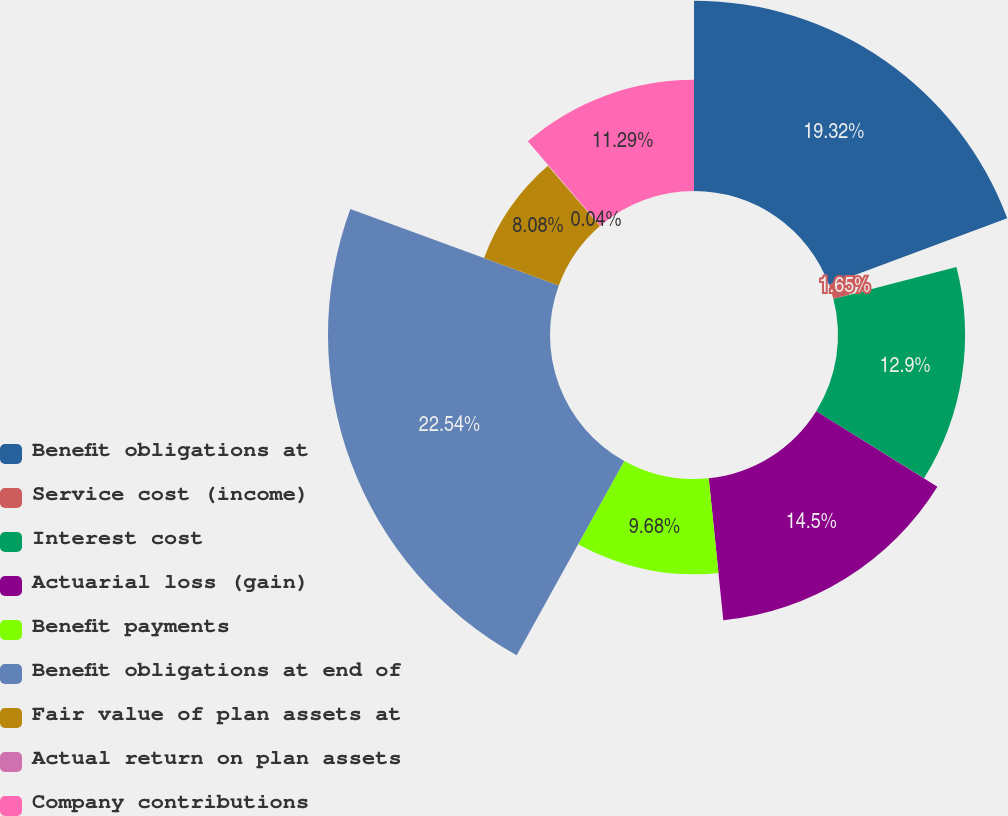Convert chart to OTSL. <chart><loc_0><loc_0><loc_500><loc_500><pie_chart><fcel>Benefit obligations at<fcel>Service cost (income)<fcel>Interest cost<fcel>Actuarial loss (gain)<fcel>Benefit payments<fcel>Benefit obligations at end of<fcel>Fair value of plan assets at<fcel>Actual return on plan assets<fcel>Company contributions<nl><fcel>19.32%<fcel>1.65%<fcel>12.9%<fcel>14.5%<fcel>9.68%<fcel>22.54%<fcel>8.08%<fcel>0.04%<fcel>11.29%<nl></chart> 